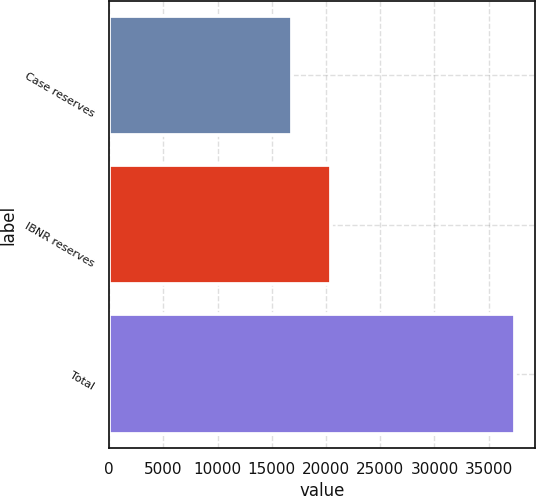Convert chart. <chart><loc_0><loc_0><loc_500><loc_500><bar_chart><fcel>Case reserves<fcel>IBNR reserves<fcel>Total<nl><fcel>16899<fcel>20492<fcel>37391<nl></chart> 